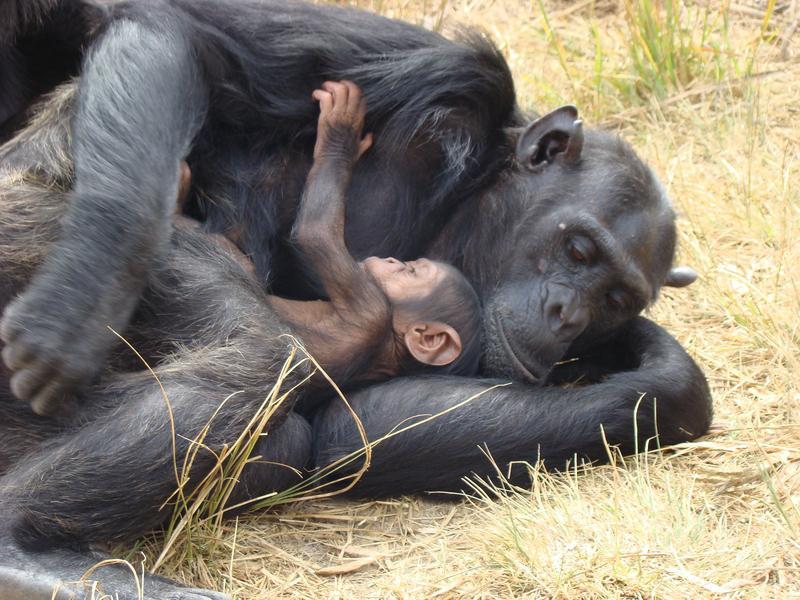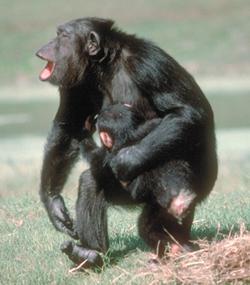The first image is the image on the left, the second image is the image on the right. Considering the images on both sides, is "An image shows at least one adult chimp looking at a tiny body lying on the ground." valid? Answer yes or no. No. The first image is the image on the left, the second image is the image on the right. For the images shown, is this caption "There is a total of four chimpanzees in the image pair." true? Answer yes or no. Yes. The first image is the image on the left, the second image is the image on the right. Analyze the images presented: Is the assertion "An image shows at least one chimp bent downward to look at a tiny body lying on the ground." valid? Answer yes or no. No. The first image is the image on the left, the second image is the image on the right. Analyze the images presented: Is the assertion "One animal in the image on the right side is standing upright." valid? Answer yes or no. Yes. 